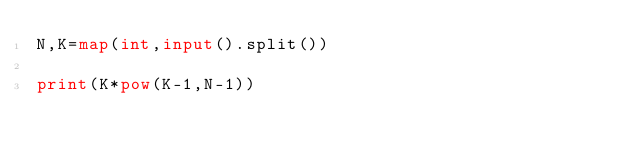Convert code to text. <code><loc_0><loc_0><loc_500><loc_500><_Python_>N,K=map(int,input().split())

print(K*pow(K-1,N-1))</code> 